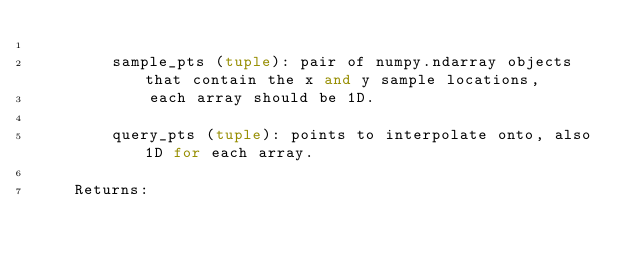Convert code to text. <code><loc_0><loc_0><loc_500><loc_500><_Python_>
        sample_pts (tuple): pair of numpy.ndarray objects that contain the x and y sample locations,
            each array should be 1D.

        query_pts (tuple): points to interpolate onto, also 1D for each array.

    Returns:</code> 